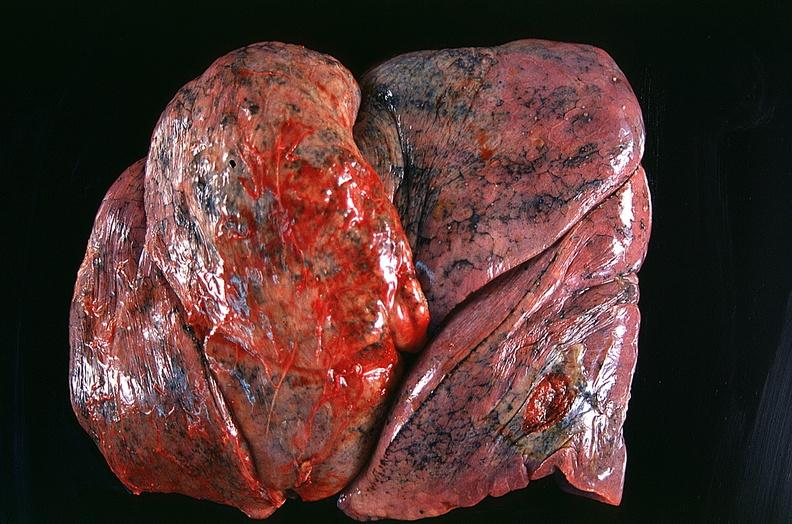s respiratory present?
Answer the question using a single word or phrase. Yes 